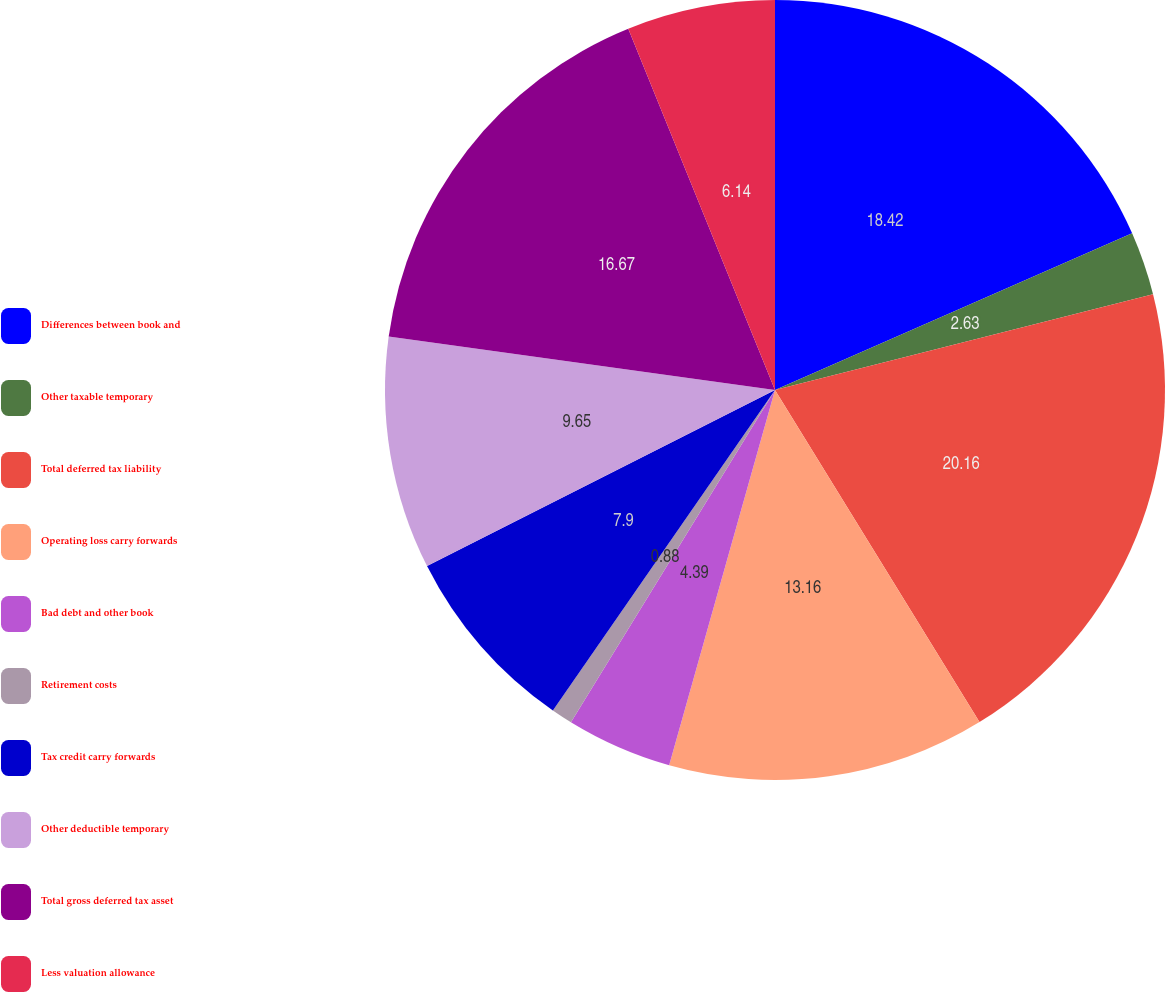<chart> <loc_0><loc_0><loc_500><loc_500><pie_chart><fcel>Differences between book and<fcel>Other taxable temporary<fcel>Total deferred tax liability<fcel>Operating loss carry forwards<fcel>Bad debt and other book<fcel>Retirement costs<fcel>Tax credit carry forwards<fcel>Other deductible temporary<fcel>Total gross deferred tax asset<fcel>Less valuation allowance<nl><fcel>18.42%<fcel>2.63%<fcel>20.17%<fcel>13.16%<fcel>4.39%<fcel>0.88%<fcel>7.9%<fcel>9.65%<fcel>16.67%<fcel>6.14%<nl></chart> 